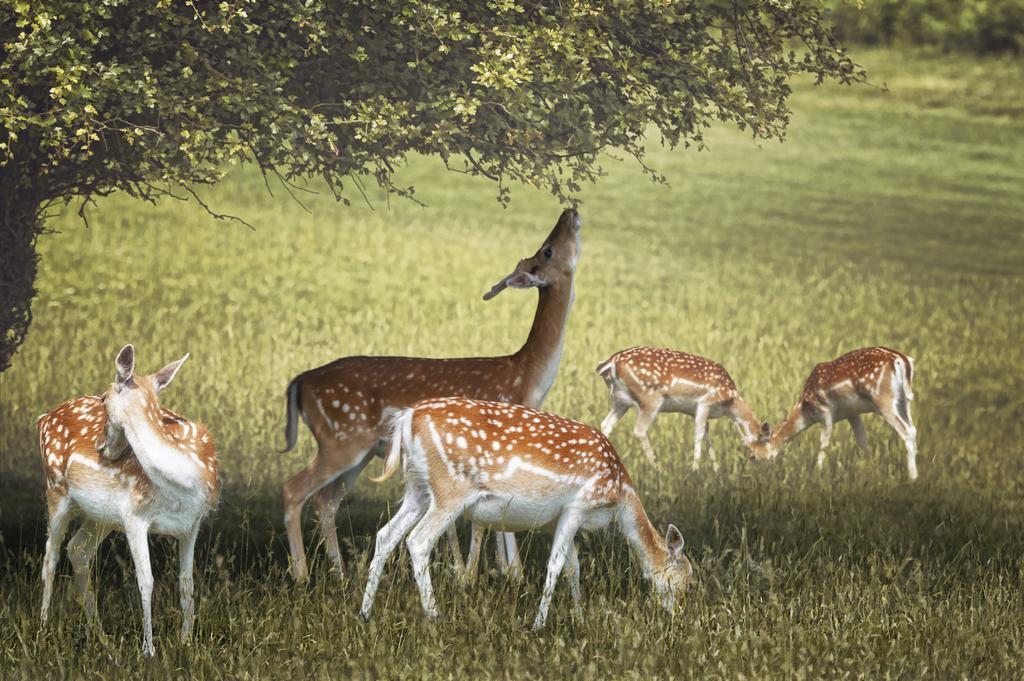In one or two sentences, can you explain what this image depicts? Land is covered with grass. Here we can see deers. This is tree. 